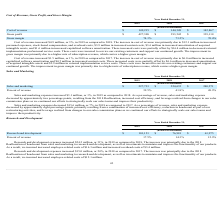According to Cornerstone Ondemand's financial document, Why did sales and marketing expenses increase between 2018 and 2019? the 2018 Reallocation, increased cost efficiency, and leverage realized from changes to our sales commission plans as we continued our efforts to strategically scale our sales teams and improve their productivity. The document states: "proximately two percentage points, resulting from the 2018 Reallocation, increased cost efficiency, and leverage realized from changes to our sales co..." Also, What was the sales and marketing expense in 2017? According to the financial document, $240,271 (in thousands). The relevant text states: "Sales and marketing $ 227,733 $ 224,635 $ 240,271..." Also, What was the sales and marketing expense in 2018? According to the financial document, $224,635 (in thousands). The relevant text states: "Sales and marketing $ 227,733 $ 224,635 $ 240,271..." Also, can you calculate: What is the change in sales and marketing between 2018 and 2019? Based on the calculation: ($227,733-$224,635), the result is 3098 (in thousands). This is based on the information: "Sales and marketing $ 227,733 $ 224,635 $ 240,271 Sales and marketing $ 227,733 $ 224,635 $ 240,271..." The key data points involved are: 224,635, 227,733. Also, can you calculate: What was the average sales and marketing expense from 2017-2019? To answer this question, I need to perform calculations using the financial data. The calculation is: ($227,733+$224,635+$240,271)/(2019-2017+1), which equals 230879.67 (in thousands). This is based on the information: "Sales and marketing $ 227,733 $ 224,635 $ 240,271 Sales and marketing $ 227,733 $ 224,635 $ 240,271 Sales and marketing $ 227,733 $ 224,635 $ 240,271..." The key data points involved are: 224,635, 227,733, 240,271. Also, can you calculate: What was the change in percent of revenue between 2018 and 2019? Based on the calculation: (39.5%-41.8%), the result is -2.3 (percentage). This is based on the information: "Percent of revenue 39.5% 41.8% 49.9% Percent of revenue 39.5% 41.8% 49.9%..." The key data points involved are: 39.5, 41.8. 